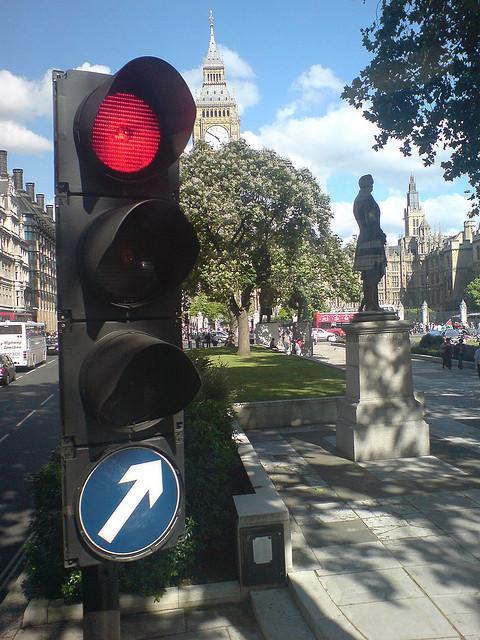How many white arrows?
Give a very brief answer. 1. 